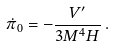<formula> <loc_0><loc_0><loc_500><loc_500>\dot { \pi } _ { 0 } = - \frac { V ^ { \prime } } { 3 M ^ { 4 } H } \, .</formula> 